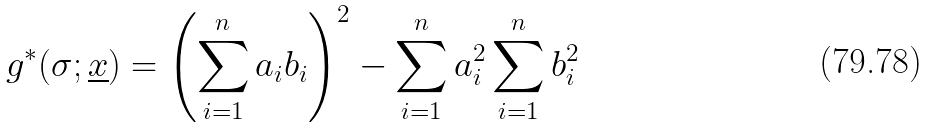Convert formula to latex. <formula><loc_0><loc_0><loc_500><loc_500>g ^ { \ast } ( \sigma ; \underline { x } ) = \left ( \sum _ { i = 1 } ^ { n } a _ { i } b _ { i } \right ) ^ { 2 } - \sum _ { i = 1 } ^ { n } a _ { i } ^ { 2 } \sum _ { i = 1 } ^ { n } b _ { i } ^ { 2 }</formula> 